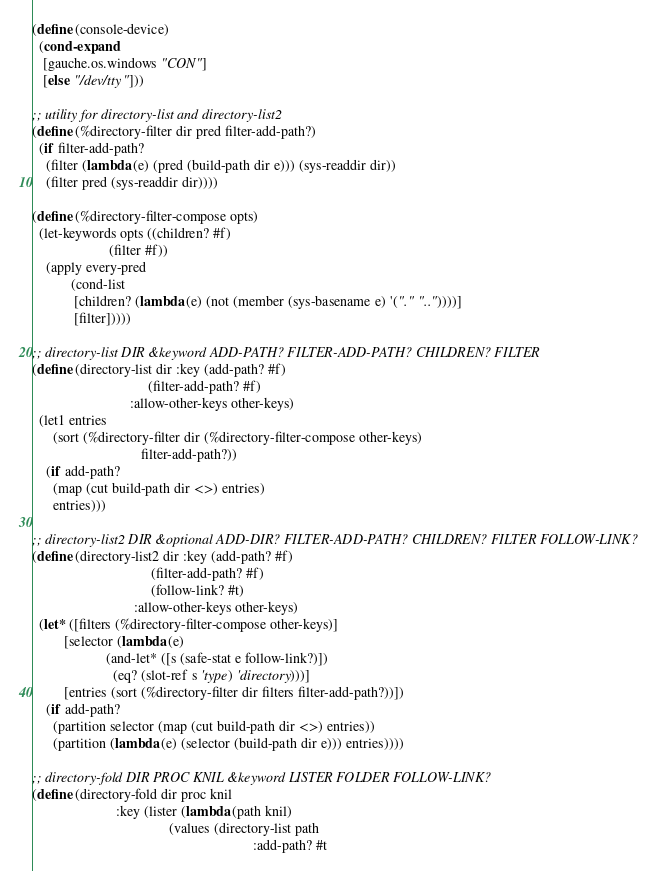<code> <loc_0><loc_0><loc_500><loc_500><_Scheme_>
(define (console-device)
  (cond-expand
   [gauche.os.windows "CON"]
   [else "/dev/tty"]))

;; utility for directory-list and directory-list2
(define (%directory-filter dir pred filter-add-path?)
  (if filter-add-path?
    (filter (lambda (e) (pred (build-path dir e))) (sys-readdir dir))
    (filter pred (sys-readdir dir))))

(define (%directory-filter-compose opts)
  (let-keywords opts ((children? #f)
                      (filter #f))
    (apply every-pred
           (cond-list
            [children? (lambda (e) (not (member (sys-basename e) '("." ".."))))]
            [filter]))))

;; directory-list DIR &keyword ADD-PATH? FILTER-ADD-PATH? CHILDREN? FILTER
(define (directory-list dir :key (add-path? #f)
                                 (filter-add-path? #f)
                            :allow-other-keys other-keys)
  (let1 entries
      (sort (%directory-filter dir (%directory-filter-compose other-keys)
                               filter-add-path?))
    (if add-path?
      (map (cut build-path dir <>) entries)
      entries)))

;; directory-list2 DIR &optional ADD-DIR? FILTER-ADD-PATH? CHILDREN? FILTER FOLLOW-LINK?
(define (directory-list2 dir :key (add-path? #f)
                                  (filter-add-path? #f)
                                  (follow-link? #t)
                             :allow-other-keys other-keys)
  (let* ([filters (%directory-filter-compose other-keys)]
         [selector (lambda (e)
                     (and-let* ([s (safe-stat e follow-link?)])
                       (eq? (slot-ref s 'type) 'directory)))]
         [entries (sort (%directory-filter dir filters filter-add-path?))])
    (if add-path?
      (partition selector (map (cut build-path dir <>) entries))
      (partition (lambda (e) (selector (build-path dir e))) entries))))

;; directory-fold DIR PROC KNIL &keyword LISTER FOLDER FOLLOW-LINK?
(define (directory-fold dir proc knil
                        :key (lister (lambda (path knil)
                                       (values (directory-list path
                                                               :add-path? #t</code> 